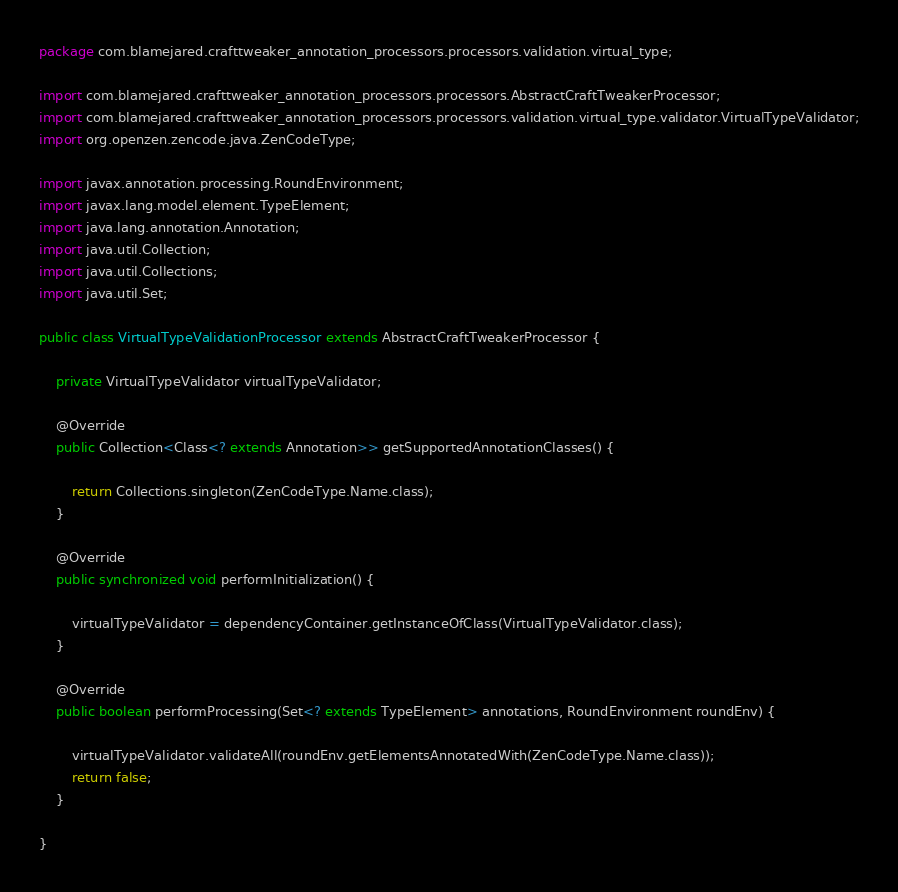Convert code to text. <code><loc_0><loc_0><loc_500><loc_500><_Java_>package com.blamejared.crafttweaker_annotation_processors.processors.validation.virtual_type;

import com.blamejared.crafttweaker_annotation_processors.processors.AbstractCraftTweakerProcessor;
import com.blamejared.crafttweaker_annotation_processors.processors.validation.virtual_type.validator.VirtualTypeValidator;
import org.openzen.zencode.java.ZenCodeType;

import javax.annotation.processing.RoundEnvironment;
import javax.lang.model.element.TypeElement;
import java.lang.annotation.Annotation;
import java.util.Collection;
import java.util.Collections;
import java.util.Set;

public class VirtualTypeValidationProcessor extends AbstractCraftTweakerProcessor {
    
    private VirtualTypeValidator virtualTypeValidator;
    
    @Override
    public Collection<Class<? extends Annotation>> getSupportedAnnotationClasses() {
        
        return Collections.singleton(ZenCodeType.Name.class);
    }
    
    @Override
    public synchronized void performInitialization() {
        
        virtualTypeValidator = dependencyContainer.getInstanceOfClass(VirtualTypeValidator.class);
    }
    
    @Override
    public boolean performProcessing(Set<? extends TypeElement> annotations, RoundEnvironment roundEnv) {
        
        virtualTypeValidator.validateAll(roundEnv.getElementsAnnotatedWith(ZenCodeType.Name.class));
        return false;
    }
    
}
</code> 